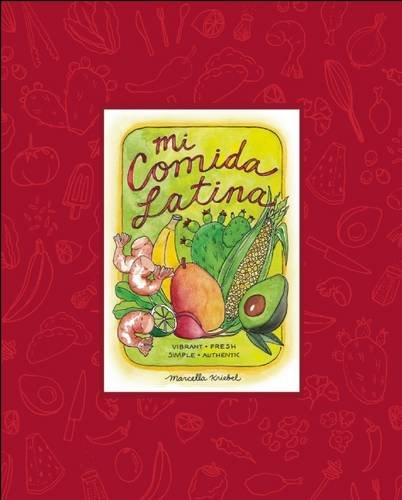Can you describe some of the dishes featured in this book? The book features a variety of dishes from different Latin American countries, such as tacos, empanadas, arepas, and ceviche, each illustrated with Marcella’s distinctive and vibrant watercolor artwork. 